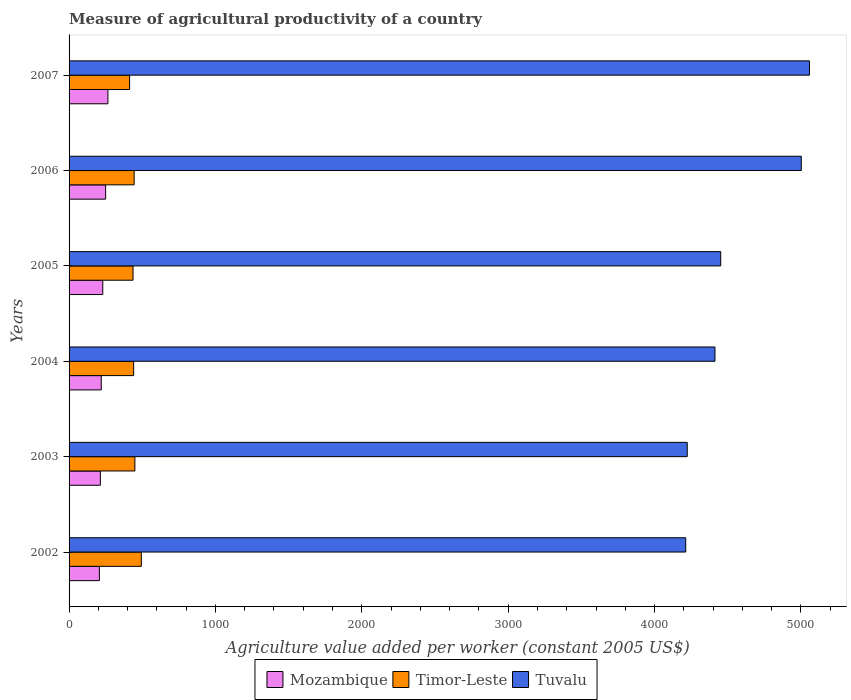How many groups of bars are there?
Provide a succinct answer. 6. Are the number of bars on each tick of the Y-axis equal?
Provide a short and direct response. Yes. How many bars are there on the 1st tick from the top?
Provide a succinct answer. 3. What is the measure of agricultural productivity in Timor-Leste in 2002?
Provide a short and direct response. 493.72. Across all years, what is the maximum measure of agricultural productivity in Mozambique?
Offer a terse response. 265.53. Across all years, what is the minimum measure of agricultural productivity in Mozambique?
Give a very brief answer. 207.13. In which year was the measure of agricultural productivity in Tuvalu maximum?
Make the answer very short. 2007. What is the total measure of agricultural productivity in Mozambique in the graph?
Make the answer very short. 1386.35. What is the difference between the measure of agricultural productivity in Mozambique in 2004 and that in 2007?
Ensure brevity in your answer.  -45.6. What is the difference between the measure of agricultural productivity in Timor-Leste in 2006 and the measure of agricultural productivity in Tuvalu in 2005?
Give a very brief answer. -4007.58. What is the average measure of agricultural productivity in Tuvalu per year?
Ensure brevity in your answer.  4560.45. In the year 2007, what is the difference between the measure of agricultural productivity in Timor-Leste and measure of agricultural productivity in Mozambique?
Offer a very short reply. 147.95. What is the ratio of the measure of agricultural productivity in Tuvalu in 2005 to that in 2007?
Make the answer very short. 0.88. Is the measure of agricultural productivity in Tuvalu in 2003 less than that in 2007?
Offer a terse response. Yes. Is the difference between the measure of agricultural productivity in Timor-Leste in 2002 and 2003 greater than the difference between the measure of agricultural productivity in Mozambique in 2002 and 2003?
Your answer should be compact. Yes. What is the difference between the highest and the second highest measure of agricultural productivity in Timor-Leste?
Your response must be concise. 44.18. What is the difference between the highest and the lowest measure of agricultural productivity in Tuvalu?
Your answer should be compact. 845.53. In how many years, is the measure of agricultural productivity in Tuvalu greater than the average measure of agricultural productivity in Tuvalu taken over all years?
Keep it short and to the point. 2. Is the sum of the measure of agricultural productivity in Timor-Leste in 2002 and 2003 greater than the maximum measure of agricultural productivity in Mozambique across all years?
Keep it short and to the point. Yes. What does the 2nd bar from the top in 2006 represents?
Your response must be concise. Timor-Leste. What does the 3rd bar from the bottom in 2002 represents?
Make the answer very short. Tuvalu. Is it the case that in every year, the sum of the measure of agricultural productivity in Timor-Leste and measure of agricultural productivity in Tuvalu is greater than the measure of agricultural productivity in Mozambique?
Offer a very short reply. Yes. How many bars are there?
Make the answer very short. 18. Are all the bars in the graph horizontal?
Give a very brief answer. Yes. How many years are there in the graph?
Ensure brevity in your answer.  6. Are the values on the major ticks of X-axis written in scientific E-notation?
Make the answer very short. No. Does the graph contain grids?
Your answer should be compact. No. Where does the legend appear in the graph?
Give a very brief answer. Bottom center. What is the title of the graph?
Your response must be concise. Measure of agricultural productivity of a country. Does "Curacao" appear as one of the legend labels in the graph?
Give a very brief answer. No. What is the label or title of the X-axis?
Your answer should be very brief. Agriculture value added per worker (constant 2005 US$). What is the label or title of the Y-axis?
Offer a very short reply. Years. What is the Agriculture value added per worker (constant 2005 US$) of Mozambique in 2002?
Ensure brevity in your answer.  207.13. What is the Agriculture value added per worker (constant 2005 US$) in Timor-Leste in 2002?
Make the answer very short. 493.72. What is the Agriculture value added per worker (constant 2005 US$) in Tuvalu in 2002?
Provide a succinct answer. 4212.99. What is the Agriculture value added per worker (constant 2005 US$) of Mozambique in 2003?
Provide a short and direct response. 213.77. What is the Agriculture value added per worker (constant 2005 US$) of Timor-Leste in 2003?
Provide a short and direct response. 449.54. What is the Agriculture value added per worker (constant 2005 US$) in Tuvalu in 2003?
Provide a succinct answer. 4223.38. What is the Agriculture value added per worker (constant 2005 US$) in Mozambique in 2004?
Your response must be concise. 219.93. What is the Agriculture value added per worker (constant 2005 US$) of Timor-Leste in 2004?
Ensure brevity in your answer.  441.13. What is the Agriculture value added per worker (constant 2005 US$) of Tuvalu in 2004?
Your response must be concise. 4412.84. What is the Agriculture value added per worker (constant 2005 US$) of Mozambique in 2005?
Your answer should be very brief. 230.29. What is the Agriculture value added per worker (constant 2005 US$) of Timor-Leste in 2005?
Your answer should be very brief. 436.89. What is the Agriculture value added per worker (constant 2005 US$) in Tuvalu in 2005?
Give a very brief answer. 4452.17. What is the Agriculture value added per worker (constant 2005 US$) in Mozambique in 2006?
Offer a terse response. 249.69. What is the Agriculture value added per worker (constant 2005 US$) of Timor-Leste in 2006?
Keep it short and to the point. 444.6. What is the Agriculture value added per worker (constant 2005 US$) in Tuvalu in 2006?
Make the answer very short. 5002.77. What is the Agriculture value added per worker (constant 2005 US$) in Mozambique in 2007?
Offer a very short reply. 265.53. What is the Agriculture value added per worker (constant 2005 US$) in Timor-Leste in 2007?
Provide a succinct answer. 413.48. What is the Agriculture value added per worker (constant 2005 US$) of Tuvalu in 2007?
Make the answer very short. 5058.52. Across all years, what is the maximum Agriculture value added per worker (constant 2005 US$) in Mozambique?
Give a very brief answer. 265.53. Across all years, what is the maximum Agriculture value added per worker (constant 2005 US$) in Timor-Leste?
Give a very brief answer. 493.72. Across all years, what is the maximum Agriculture value added per worker (constant 2005 US$) of Tuvalu?
Ensure brevity in your answer.  5058.52. Across all years, what is the minimum Agriculture value added per worker (constant 2005 US$) in Mozambique?
Your response must be concise. 207.13. Across all years, what is the minimum Agriculture value added per worker (constant 2005 US$) of Timor-Leste?
Your response must be concise. 413.48. Across all years, what is the minimum Agriculture value added per worker (constant 2005 US$) in Tuvalu?
Your answer should be very brief. 4212.99. What is the total Agriculture value added per worker (constant 2005 US$) in Mozambique in the graph?
Give a very brief answer. 1386.35. What is the total Agriculture value added per worker (constant 2005 US$) of Timor-Leste in the graph?
Your answer should be compact. 2679.36. What is the total Agriculture value added per worker (constant 2005 US$) of Tuvalu in the graph?
Offer a terse response. 2.74e+04. What is the difference between the Agriculture value added per worker (constant 2005 US$) of Mozambique in 2002 and that in 2003?
Your answer should be very brief. -6.64. What is the difference between the Agriculture value added per worker (constant 2005 US$) in Timor-Leste in 2002 and that in 2003?
Keep it short and to the point. 44.18. What is the difference between the Agriculture value added per worker (constant 2005 US$) of Tuvalu in 2002 and that in 2003?
Offer a very short reply. -10.39. What is the difference between the Agriculture value added per worker (constant 2005 US$) of Mozambique in 2002 and that in 2004?
Offer a very short reply. -12.8. What is the difference between the Agriculture value added per worker (constant 2005 US$) in Timor-Leste in 2002 and that in 2004?
Make the answer very short. 52.6. What is the difference between the Agriculture value added per worker (constant 2005 US$) of Tuvalu in 2002 and that in 2004?
Your response must be concise. -199.85. What is the difference between the Agriculture value added per worker (constant 2005 US$) in Mozambique in 2002 and that in 2005?
Provide a succinct answer. -23.16. What is the difference between the Agriculture value added per worker (constant 2005 US$) in Timor-Leste in 2002 and that in 2005?
Provide a short and direct response. 56.83. What is the difference between the Agriculture value added per worker (constant 2005 US$) in Tuvalu in 2002 and that in 2005?
Your answer should be compact. -239.18. What is the difference between the Agriculture value added per worker (constant 2005 US$) in Mozambique in 2002 and that in 2006?
Provide a short and direct response. -42.56. What is the difference between the Agriculture value added per worker (constant 2005 US$) in Timor-Leste in 2002 and that in 2006?
Offer a very short reply. 49.13. What is the difference between the Agriculture value added per worker (constant 2005 US$) of Tuvalu in 2002 and that in 2006?
Your answer should be compact. -789.78. What is the difference between the Agriculture value added per worker (constant 2005 US$) in Mozambique in 2002 and that in 2007?
Offer a terse response. -58.4. What is the difference between the Agriculture value added per worker (constant 2005 US$) of Timor-Leste in 2002 and that in 2007?
Make the answer very short. 80.24. What is the difference between the Agriculture value added per worker (constant 2005 US$) of Tuvalu in 2002 and that in 2007?
Keep it short and to the point. -845.53. What is the difference between the Agriculture value added per worker (constant 2005 US$) in Mozambique in 2003 and that in 2004?
Offer a very short reply. -6.16. What is the difference between the Agriculture value added per worker (constant 2005 US$) in Timor-Leste in 2003 and that in 2004?
Your response must be concise. 8.41. What is the difference between the Agriculture value added per worker (constant 2005 US$) in Tuvalu in 2003 and that in 2004?
Keep it short and to the point. -189.47. What is the difference between the Agriculture value added per worker (constant 2005 US$) in Mozambique in 2003 and that in 2005?
Offer a terse response. -16.52. What is the difference between the Agriculture value added per worker (constant 2005 US$) of Timor-Leste in 2003 and that in 2005?
Offer a very short reply. 12.65. What is the difference between the Agriculture value added per worker (constant 2005 US$) in Tuvalu in 2003 and that in 2005?
Your answer should be very brief. -228.79. What is the difference between the Agriculture value added per worker (constant 2005 US$) of Mozambique in 2003 and that in 2006?
Make the answer very short. -35.92. What is the difference between the Agriculture value added per worker (constant 2005 US$) in Timor-Leste in 2003 and that in 2006?
Make the answer very short. 4.95. What is the difference between the Agriculture value added per worker (constant 2005 US$) in Tuvalu in 2003 and that in 2006?
Ensure brevity in your answer.  -779.4. What is the difference between the Agriculture value added per worker (constant 2005 US$) in Mozambique in 2003 and that in 2007?
Keep it short and to the point. -51.76. What is the difference between the Agriculture value added per worker (constant 2005 US$) of Timor-Leste in 2003 and that in 2007?
Give a very brief answer. 36.06. What is the difference between the Agriculture value added per worker (constant 2005 US$) in Tuvalu in 2003 and that in 2007?
Provide a short and direct response. -835.14. What is the difference between the Agriculture value added per worker (constant 2005 US$) of Mozambique in 2004 and that in 2005?
Make the answer very short. -10.36. What is the difference between the Agriculture value added per worker (constant 2005 US$) of Timor-Leste in 2004 and that in 2005?
Provide a short and direct response. 4.23. What is the difference between the Agriculture value added per worker (constant 2005 US$) of Tuvalu in 2004 and that in 2005?
Ensure brevity in your answer.  -39.33. What is the difference between the Agriculture value added per worker (constant 2005 US$) of Mozambique in 2004 and that in 2006?
Provide a short and direct response. -29.76. What is the difference between the Agriculture value added per worker (constant 2005 US$) in Timor-Leste in 2004 and that in 2006?
Offer a terse response. -3.47. What is the difference between the Agriculture value added per worker (constant 2005 US$) in Tuvalu in 2004 and that in 2006?
Your answer should be very brief. -589.93. What is the difference between the Agriculture value added per worker (constant 2005 US$) in Mozambique in 2004 and that in 2007?
Keep it short and to the point. -45.6. What is the difference between the Agriculture value added per worker (constant 2005 US$) of Timor-Leste in 2004 and that in 2007?
Provide a short and direct response. 27.65. What is the difference between the Agriculture value added per worker (constant 2005 US$) of Tuvalu in 2004 and that in 2007?
Provide a short and direct response. -645.68. What is the difference between the Agriculture value added per worker (constant 2005 US$) of Mozambique in 2005 and that in 2006?
Ensure brevity in your answer.  -19.4. What is the difference between the Agriculture value added per worker (constant 2005 US$) of Timor-Leste in 2005 and that in 2006?
Provide a short and direct response. -7.7. What is the difference between the Agriculture value added per worker (constant 2005 US$) in Tuvalu in 2005 and that in 2006?
Offer a terse response. -550.6. What is the difference between the Agriculture value added per worker (constant 2005 US$) in Mozambique in 2005 and that in 2007?
Make the answer very short. -35.24. What is the difference between the Agriculture value added per worker (constant 2005 US$) of Timor-Leste in 2005 and that in 2007?
Provide a short and direct response. 23.41. What is the difference between the Agriculture value added per worker (constant 2005 US$) in Tuvalu in 2005 and that in 2007?
Your answer should be very brief. -606.35. What is the difference between the Agriculture value added per worker (constant 2005 US$) of Mozambique in 2006 and that in 2007?
Your response must be concise. -15.84. What is the difference between the Agriculture value added per worker (constant 2005 US$) of Timor-Leste in 2006 and that in 2007?
Your answer should be very brief. 31.12. What is the difference between the Agriculture value added per worker (constant 2005 US$) of Tuvalu in 2006 and that in 2007?
Offer a terse response. -55.75. What is the difference between the Agriculture value added per worker (constant 2005 US$) in Mozambique in 2002 and the Agriculture value added per worker (constant 2005 US$) in Timor-Leste in 2003?
Your answer should be very brief. -242.41. What is the difference between the Agriculture value added per worker (constant 2005 US$) of Mozambique in 2002 and the Agriculture value added per worker (constant 2005 US$) of Tuvalu in 2003?
Make the answer very short. -4016.25. What is the difference between the Agriculture value added per worker (constant 2005 US$) of Timor-Leste in 2002 and the Agriculture value added per worker (constant 2005 US$) of Tuvalu in 2003?
Provide a short and direct response. -3729.66. What is the difference between the Agriculture value added per worker (constant 2005 US$) of Mozambique in 2002 and the Agriculture value added per worker (constant 2005 US$) of Timor-Leste in 2004?
Your response must be concise. -234. What is the difference between the Agriculture value added per worker (constant 2005 US$) of Mozambique in 2002 and the Agriculture value added per worker (constant 2005 US$) of Tuvalu in 2004?
Give a very brief answer. -4205.71. What is the difference between the Agriculture value added per worker (constant 2005 US$) of Timor-Leste in 2002 and the Agriculture value added per worker (constant 2005 US$) of Tuvalu in 2004?
Your answer should be very brief. -3919.12. What is the difference between the Agriculture value added per worker (constant 2005 US$) of Mozambique in 2002 and the Agriculture value added per worker (constant 2005 US$) of Timor-Leste in 2005?
Provide a short and direct response. -229.76. What is the difference between the Agriculture value added per worker (constant 2005 US$) in Mozambique in 2002 and the Agriculture value added per worker (constant 2005 US$) in Tuvalu in 2005?
Keep it short and to the point. -4245.04. What is the difference between the Agriculture value added per worker (constant 2005 US$) in Timor-Leste in 2002 and the Agriculture value added per worker (constant 2005 US$) in Tuvalu in 2005?
Your answer should be compact. -3958.45. What is the difference between the Agriculture value added per worker (constant 2005 US$) in Mozambique in 2002 and the Agriculture value added per worker (constant 2005 US$) in Timor-Leste in 2006?
Provide a succinct answer. -237.47. What is the difference between the Agriculture value added per worker (constant 2005 US$) in Mozambique in 2002 and the Agriculture value added per worker (constant 2005 US$) in Tuvalu in 2006?
Your answer should be compact. -4795.64. What is the difference between the Agriculture value added per worker (constant 2005 US$) of Timor-Leste in 2002 and the Agriculture value added per worker (constant 2005 US$) of Tuvalu in 2006?
Ensure brevity in your answer.  -4509.05. What is the difference between the Agriculture value added per worker (constant 2005 US$) of Mozambique in 2002 and the Agriculture value added per worker (constant 2005 US$) of Timor-Leste in 2007?
Provide a succinct answer. -206.35. What is the difference between the Agriculture value added per worker (constant 2005 US$) of Mozambique in 2002 and the Agriculture value added per worker (constant 2005 US$) of Tuvalu in 2007?
Your response must be concise. -4851.39. What is the difference between the Agriculture value added per worker (constant 2005 US$) of Timor-Leste in 2002 and the Agriculture value added per worker (constant 2005 US$) of Tuvalu in 2007?
Ensure brevity in your answer.  -4564.8. What is the difference between the Agriculture value added per worker (constant 2005 US$) of Mozambique in 2003 and the Agriculture value added per worker (constant 2005 US$) of Timor-Leste in 2004?
Your answer should be very brief. -227.35. What is the difference between the Agriculture value added per worker (constant 2005 US$) in Mozambique in 2003 and the Agriculture value added per worker (constant 2005 US$) in Tuvalu in 2004?
Offer a very short reply. -4199.07. What is the difference between the Agriculture value added per worker (constant 2005 US$) in Timor-Leste in 2003 and the Agriculture value added per worker (constant 2005 US$) in Tuvalu in 2004?
Provide a succinct answer. -3963.3. What is the difference between the Agriculture value added per worker (constant 2005 US$) in Mozambique in 2003 and the Agriculture value added per worker (constant 2005 US$) in Timor-Leste in 2005?
Make the answer very short. -223.12. What is the difference between the Agriculture value added per worker (constant 2005 US$) in Mozambique in 2003 and the Agriculture value added per worker (constant 2005 US$) in Tuvalu in 2005?
Provide a succinct answer. -4238.4. What is the difference between the Agriculture value added per worker (constant 2005 US$) of Timor-Leste in 2003 and the Agriculture value added per worker (constant 2005 US$) of Tuvalu in 2005?
Provide a short and direct response. -4002.63. What is the difference between the Agriculture value added per worker (constant 2005 US$) in Mozambique in 2003 and the Agriculture value added per worker (constant 2005 US$) in Timor-Leste in 2006?
Provide a succinct answer. -230.82. What is the difference between the Agriculture value added per worker (constant 2005 US$) of Mozambique in 2003 and the Agriculture value added per worker (constant 2005 US$) of Tuvalu in 2006?
Offer a terse response. -4789. What is the difference between the Agriculture value added per worker (constant 2005 US$) of Timor-Leste in 2003 and the Agriculture value added per worker (constant 2005 US$) of Tuvalu in 2006?
Your response must be concise. -4553.23. What is the difference between the Agriculture value added per worker (constant 2005 US$) of Mozambique in 2003 and the Agriculture value added per worker (constant 2005 US$) of Timor-Leste in 2007?
Your answer should be very brief. -199.71. What is the difference between the Agriculture value added per worker (constant 2005 US$) in Mozambique in 2003 and the Agriculture value added per worker (constant 2005 US$) in Tuvalu in 2007?
Provide a short and direct response. -4844.75. What is the difference between the Agriculture value added per worker (constant 2005 US$) of Timor-Leste in 2003 and the Agriculture value added per worker (constant 2005 US$) of Tuvalu in 2007?
Provide a short and direct response. -4608.98. What is the difference between the Agriculture value added per worker (constant 2005 US$) of Mozambique in 2004 and the Agriculture value added per worker (constant 2005 US$) of Timor-Leste in 2005?
Offer a terse response. -216.96. What is the difference between the Agriculture value added per worker (constant 2005 US$) in Mozambique in 2004 and the Agriculture value added per worker (constant 2005 US$) in Tuvalu in 2005?
Give a very brief answer. -4232.24. What is the difference between the Agriculture value added per worker (constant 2005 US$) of Timor-Leste in 2004 and the Agriculture value added per worker (constant 2005 US$) of Tuvalu in 2005?
Offer a terse response. -4011.05. What is the difference between the Agriculture value added per worker (constant 2005 US$) of Mozambique in 2004 and the Agriculture value added per worker (constant 2005 US$) of Timor-Leste in 2006?
Your response must be concise. -224.66. What is the difference between the Agriculture value added per worker (constant 2005 US$) of Mozambique in 2004 and the Agriculture value added per worker (constant 2005 US$) of Tuvalu in 2006?
Provide a succinct answer. -4782.84. What is the difference between the Agriculture value added per worker (constant 2005 US$) in Timor-Leste in 2004 and the Agriculture value added per worker (constant 2005 US$) in Tuvalu in 2006?
Ensure brevity in your answer.  -4561.65. What is the difference between the Agriculture value added per worker (constant 2005 US$) in Mozambique in 2004 and the Agriculture value added per worker (constant 2005 US$) in Timor-Leste in 2007?
Make the answer very short. -193.55. What is the difference between the Agriculture value added per worker (constant 2005 US$) of Mozambique in 2004 and the Agriculture value added per worker (constant 2005 US$) of Tuvalu in 2007?
Make the answer very short. -4838.59. What is the difference between the Agriculture value added per worker (constant 2005 US$) in Timor-Leste in 2004 and the Agriculture value added per worker (constant 2005 US$) in Tuvalu in 2007?
Your response must be concise. -4617.4. What is the difference between the Agriculture value added per worker (constant 2005 US$) in Mozambique in 2005 and the Agriculture value added per worker (constant 2005 US$) in Timor-Leste in 2006?
Provide a succinct answer. -214.3. What is the difference between the Agriculture value added per worker (constant 2005 US$) of Mozambique in 2005 and the Agriculture value added per worker (constant 2005 US$) of Tuvalu in 2006?
Provide a succinct answer. -4772.48. What is the difference between the Agriculture value added per worker (constant 2005 US$) of Timor-Leste in 2005 and the Agriculture value added per worker (constant 2005 US$) of Tuvalu in 2006?
Ensure brevity in your answer.  -4565.88. What is the difference between the Agriculture value added per worker (constant 2005 US$) in Mozambique in 2005 and the Agriculture value added per worker (constant 2005 US$) in Timor-Leste in 2007?
Give a very brief answer. -183.19. What is the difference between the Agriculture value added per worker (constant 2005 US$) of Mozambique in 2005 and the Agriculture value added per worker (constant 2005 US$) of Tuvalu in 2007?
Ensure brevity in your answer.  -4828.23. What is the difference between the Agriculture value added per worker (constant 2005 US$) in Timor-Leste in 2005 and the Agriculture value added per worker (constant 2005 US$) in Tuvalu in 2007?
Provide a succinct answer. -4621.63. What is the difference between the Agriculture value added per worker (constant 2005 US$) in Mozambique in 2006 and the Agriculture value added per worker (constant 2005 US$) in Timor-Leste in 2007?
Keep it short and to the point. -163.79. What is the difference between the Agriculture value added per worker (constant 2005 US$) of Mozambique in 2006 and the Agriculture value added per worker (constant 2005 US$) of Tuvalu in 2007?
Provide a short and direct response. -4808.83. What is the difference between the Agriculture value added per worker (constant 2005 US$) of Timor-Leste in 2006 and the Agriculture value added per worker (constant 2005 US$) of Tuvalu in 2007?
Keep it short and to the point. -4613.93. What is the average Agriculture value added per worker (constant 2005 US$) in Mozambique per year?
Offer a terse response. 231.06. What is the average Agriculture value added per worker (constant 2005 US$) of Timor-Leste per year?
Your answer should be very brief. 446.56. What is the average Agriculture value added per worker (constant 2005 US$) of Tuvalu per year?
Give a very brief answer. 4560.45. In the year 2002, what is the difference between the Agriculture value added per worker (constant 2005 US$) of Mozambique and Agriculture value added per worker (constant 2005 US$) of Timor-Leste?
Ensure brevity in your answer.  -286.59. In the year 2002, what is the difference between the Agriculture value added per worker (constant 2005 US$) in Mozambique and Agriculture value added per worker (constant 2005 US$) in Tuvalu?
Offer a terse response. -4005.86. In the year 2002, what is the difference between the Agriculture value added per worker (constant 2005 US$) of Timor-Leste and Agriculture value added per worker (constant 2005 US$) of Tuvalu?
Offer a terse response. -3719.27. In the year 2003, what is the difference between the Agriculture value added per worker (constant 2005 US$) of Mozambique and Agriculture value added per worker (constant 2005 US$) of Timor-Leste?
Your answer should be compact. -235.77. In the year 2003, what is the difference between the Agriculture value added per worker (constant 2005 US$) of Mozambique and Agriculture value added per worker (constant 2005 US$) of Tuvalu?
Give a very brief answer. -4009.6. In the year 2003, what is the difference between the Agriculture value added per worker (constant 2005 US$) in Timor-Leste and Agriculture value added per worker (constant 2005 US$) in Tuvalu?
Offer a terse response. -3773.84. In the year 2004, what is the difference between the Agriculture value added per worker (constant 2005 US$) in Mozambique and Agriculture value added per worker (constant 2005 US$) in Timor-Leste?
Keep it short and to the point. -221.19. In the year 2004, what is the difference between the Agriculture value added per worker (constant 2005 US$) in Mozambique and Agriculture value added per worker (constant 2005 US$) in Tuvalu?
Provide a succinct answer. -4192.91. In the year 2004, what is the difference between the Agriculture value added per worker (constant 2005 US$) in Timor-Leste and Agriculture value added per worker (constant 2005 US$) in Tuvalu?
Make the answer very short. -3971.72. In the year 2005, what is the difference between the Agriculture value added per worker (constant 2005 US$) of Mozambique and Agriculture value added per worker (constant 2005 US$) of Timor-Leste?
Your response must be concise. -206.6. In the year 2005, what is the difference between the Agriculture value added per worker (constant 2005 US$) of Mozambique and Agriculture value added per worker (constant 2005 US$) of Tuvalu?
Give a very brief answer. -4221.88. In the year 2005, what is the difference between the Agriculture value added per worker (constant 2005 US$) of Timor-Leste and Agriculture value added per worker (constant 2005 US$) of Tuvalu?
Make the answer very short. -4015.28. In the year 2006, what is the difference between the Agriculture value added per worker (constant 2005 US$) of Mozambique and Agriculture value added per worker (constant 2005 US$) of Timor-Leste?
Give a very brief answer. -194.9. In the year 2006, what is the difference between the Agriculture value added per worker (constant 2005 US$) in Mozambique and Agriculture value added per worker (constant 2005 US$) in Tuvalu?
Your response must be concise. -4753.08. In the year 2006, what is the difference between the Agriculture value added per worker (constant 2005 US$) in Timor-Leste and Agriculture value added per worker (constant 2005 US$) in Tuvalu?
Give a very brief answer. -4558.18. In the year 2007, what is the difference between the Agriculture value added per worker (constant 2005 US$) in Mozambique and Agriculture value added per worker (constant 2005 US$) in Timor-Leste?
Offer a terse response. -147.95. In the year 2007, what is the difference between the Agriculture value added per worker (constant 2005 US$) of Mozambique and Agriculture value added per worker (constant 2005 US$) of Tuvalu?
Offer a very short reply. -4792.99. In the year 2007, what is the difference between the Agriculture value added per worker (constant 2005 US$) in Timor-Leste and Agriculture value added per worker (constant 2005 US$) in Tuvalu?
Keep it short and to the point. -4645.04. What is the ratio of the Agriculture value added per worker (constant 2005 US$) in Mozambique in 2002 to that in 2003?
Offer a terse response. 0.97. What is the ratio of the Agriculture value added per worker (constant 2005 US$) in Timor-Leste in 2002 to that in 2003?
Ensure brevity in your answer.  1.1. What is the ratio of the Agriculture value added per worker (constant 2005 US$) in Tuvalu in 2002 to that in 2003?
Make the answer very short. 1. What is the ratio of the Agriculture value added per worker (constant 2005 US$) of Mozambique in 2002 to that in 2004?
Keep it short and to the point. 0.94. What is the ratio of the Agriculture value added per worker (constant 2005 US$) in Timor-Leste in 2002 to that in 2004?
Make the answer very short. 1.12. What is the ratio of the Agriculture value added per worker (constant 2005 US$) in Tuvalu in 2002 to that in 2004?
Your answer should be compact. 0.95. What is the ratio of the Agriculture value added per worker (constant 2005 US$) of Mozambique in 2002 to that in 2005?
Provide a short and direct response. 0.9. What is the ratio of the Agriculture value added per worker (constant 2005 US$) in Timor-Leste in 2002 to that in 2005?
Your response must be concise. 1.13. What is the ratio of the Agriculture value added per worker (constant 2005 US$) of Tuvalu in 2002 to that in 2005?
Your answer should be compact. 0.95. What is the ratio of the Agriculture value added per worker (constant 2005 US$) of Mozambique in 2002 to that in 2006?
Make the answer very short. 0.83. What is the ratio of the Agriculture value added per worker (constant 2005 US$) of Timor-Leste in 2002 to that in 2006?
Ensure brevity in your answer.  1.11. What is the ratio of the Agriculture value added per worker (constant 2005 US$) of Tuvalu in 2002 to that in 2006?
Offer a very short reply. 0.84. What is the ratio of the Agriculture value added per worker (constant 2005 US$) in Mozambique in 2002 to that in 2007?
Your answer should be compact. 0.78. What is the ratio of the Agriculture value added per worker (constant 2005 US$) of Timor-Leste in 2002 to that in 2007?
Keep it short and to the point. 1.19. What is the ratio of the Agriculture value added per worker (constant 2005 US$) of Tuvalu in 2002 to that in 2007?
Your response must be concise. 0.83. What is the ratio of the Agriculture value added per worker (constant 2005 US$) in Timor-Leste in 2003 to that in 2004?
Your answer should be compact. 1.02. What is the ratio of the Agriculture value added per worker (constant 2005 US$) of Tuvalu in 2003 to that in 2004?
Ensure brevity in your answer.  0.96. What is the ratio of the Agriculture value added per worker (constant 2005 US$) of Mozambique in 2003 to that in 2005?
Your answer should be very brief. 0.93. What is the ratio of the Agriculture value added per worker (constant 2005 US$) in Timor-Leste in 2003 to that in 2005?
Keep it short and to the point. 1.03. What is the ratio of the Agriculture value added per worker (constant 2005 US$) of Tuvalu in 2003 to that in 2005?
Your answer should be compact. 0.95. What is the ratio of the Agriculture value added per worker (constant 2005 US$) in Mozambique in 2003 to that in 2006?
Offer a very short reply. 0.86. What is the ratio of the Agriculture value added per worker (constant 2005 US$) in Timor-Leste in 2003 to that in 2006?
Your response must be concise. 1.01. What is the ratio of the Agriculture value added per worker (constant 2005 US$) in Tuvalu in 2003 to that in 2006?
Offer a very short reply. 0.84. What is the ratio of the Agriculture value added per worker (constant 2005 US$) in Mozambique in 2003 to that in 2007?
Your answer should be compact. 0.81. What is the ratio of the Agriculture value added per worker (constant 2005 US$) of Timor-Leste in 2003 to that in 2007?
Make the answer very short. 1.09. What is the ratio of the Agriculture value added per worker (constant 2005 US$) of Tuvalu in 2003 to that in 2007?
Offer a very short reply. 0.83. What is the ratio of the Agriculture value added per worker (constant 2005 US$) of Mozambique in 2004 to that in 2005?
Ensure brevity in your answer.  0.95. What is the ratio of the Agriculture value added per worker (constant 2005 US$) of Timor-Leste in 2004 to that in 2005?
Make the answer very short. 1.01. What is the ratio of the Agriculture value added per worker (constant 2005 US$) of Mozambique in 2004 to that in 2006?
Your answer should be very brief. 0.88. What is the ratio of the Agriculture value added per worker (constant 2005 US$) of Timor-Leste in 2004 to that in 2006?
Ensure brevity in your answer.  0.99. What is the ratio of the Agriculture value added per worker (constant 2005 US$) in Tuvalu in 2004 to that in 2006?
Keep it short and to the point. 0.88. What is the ratio of the Agriculture value added per worker (constant 2005 US$) in Mozambique in 2004 to that in 2007?
Provide a succinct answer. 0.83. What is the ratio of the Agriculture value added per worker (constant 2005 US$) of Timor-Leste in 2004 to that in 2007?
Give a very brief answer. 1.07. What is the ratio of the Agriculture value added per worker (constant 2005 US$) of Tuvalu in 2004 to that in 2007?
Offer a terse response. 0.87. What is the ratio of the Agriculture value added per worker (constant 2005 US$) in Mozambique in 2005 to that in 2006?
Provide a short and direct response. 0.92. What is the ratio of the Agriculture value added per worker (constant 2005 US$) of Timor-Leste in 2005 to that in 2006?
Give a very brief answer. 0.98. What is the ratio of the Agriculture value added per worker (constant 2005 US$) of Tuvalu in 2005 to that in 2006?
Your answer should be very brief. 0.89. What is the ratio of the Agriculture value added per worker (constant 2005 US$) of Mozambique in 2005 to that in 2007?
Ensure brevity in your answer.  0.87. What is the ratio of the Agriculture value added per worker (constant 2005 US$) in Timor-Leste in 2005 to that in 2007?
Your response must be concise. 1.06. What is the ratio of the Agriculture value added per worker (constant 2005 US$) of Tuvalu in 2005 to that in 2007?
Give a very brief answer. 0.88. What is the ratio of the Agriculture value added per worker (constant 2005 US$) in Mozambique in 2006 to that in 2007?
Offer a very short reply. 0.94. What is the ratio of the Agriculture value added per worker (constant 2005 US$) of Timor-Leste in 2006 to that in 2007?
Keep it short and to the point. 1.08. What is the ratio of the Agriculture value added per worker (constant 2005 US$) of Tuvalu in 2006 to that in 2007?
Your answer should be very brief. 0.99. What is the difference between the highest and the second highest Agriculture value added per worker (constant 2005 US$) in Mozambique?
Your answer should be very brief. 15.84. What is the difference between the highest and the second highest Agriculture value added per worker (constant 2005 US$) of Timor-Leste?
Your answer should be compact. 44.18. What is the difference between the highest and the second highest Agriculture value added per worker (constant 2005 US$) in Tuvalu?
Ensure brevity in your answer.  55.75. What is the difference between the highest and the lowest Agriculture value added per worker (constant 2005 US$) in Mozambique?
Provide a short and direct response. 58.4. What is the difference between the highest and the lowest Agriculture value added per worker (constant 2005 US$) in Timor-Leste?
Your answer should be very brief. 80.24. What is the difference between the highest and the lowest Agriculture value added per worker (constant 2005 US$) in Tuvalu?
Your response must be concise. 845.53. 